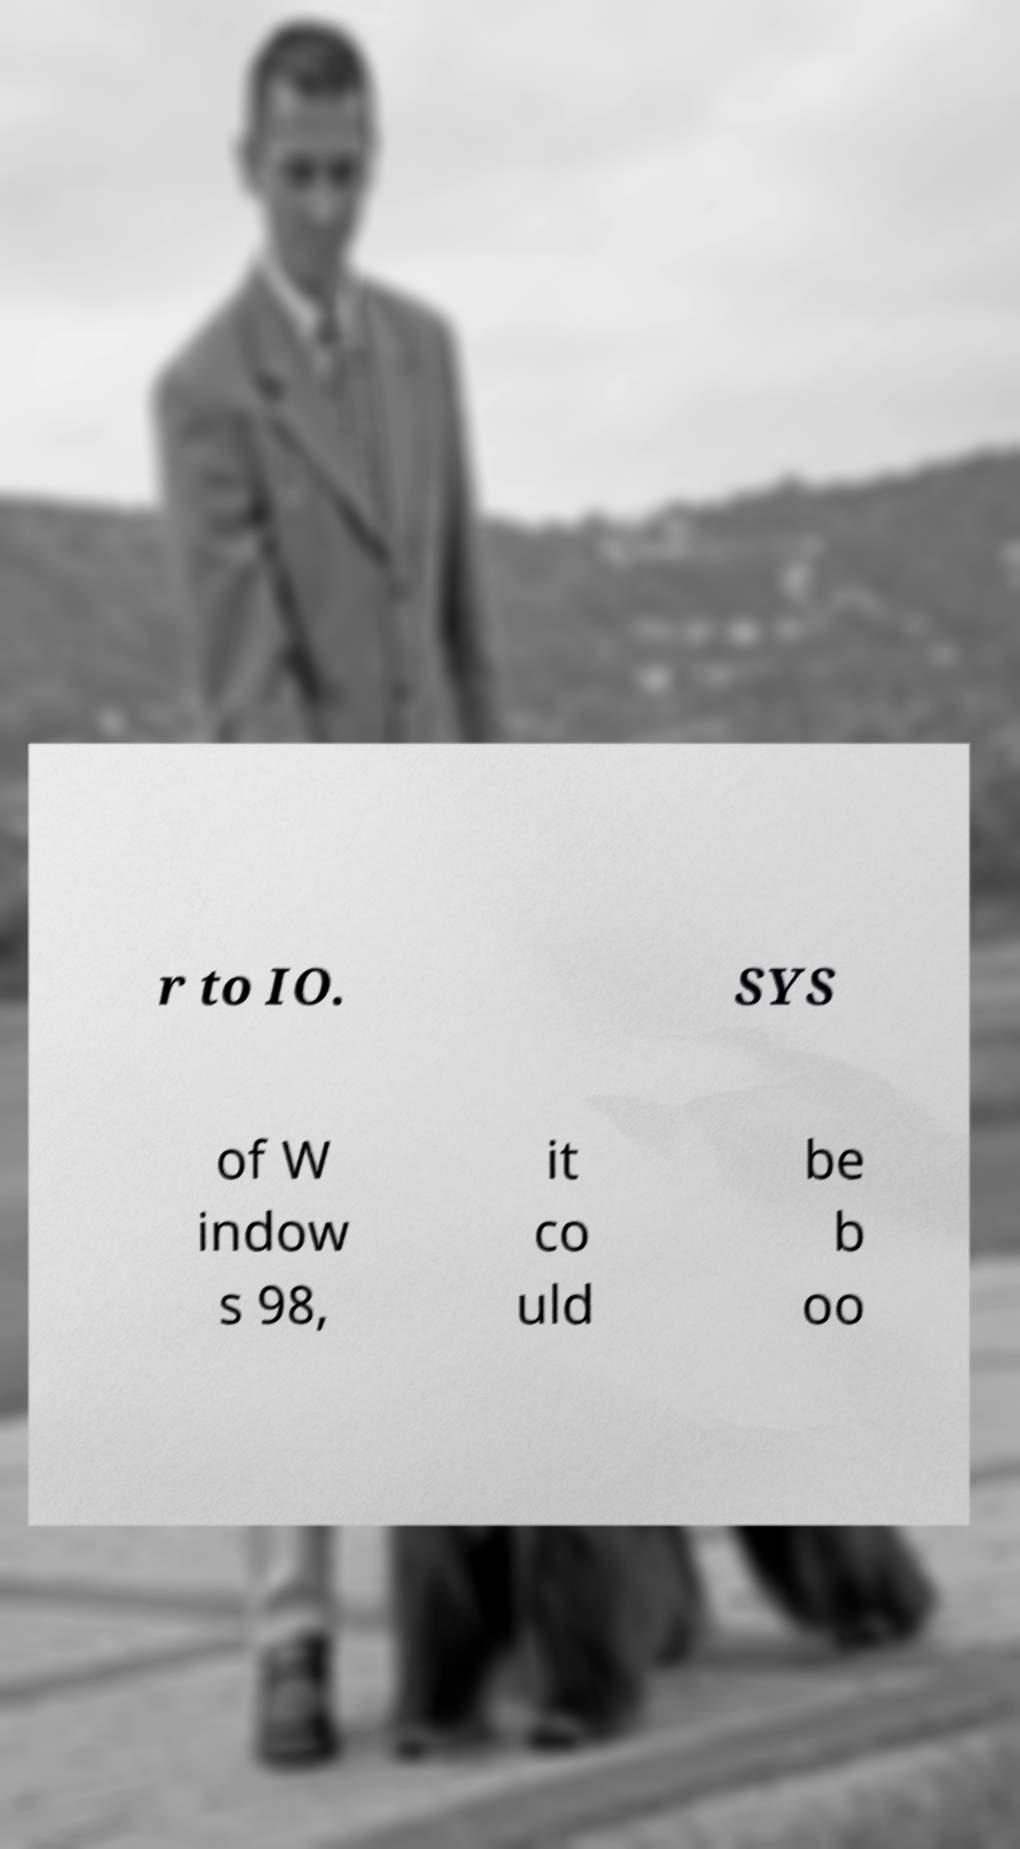Please identify and transcribe the text found in this image. r to IO. SYS of W indow s 98, it co uld be b oo 